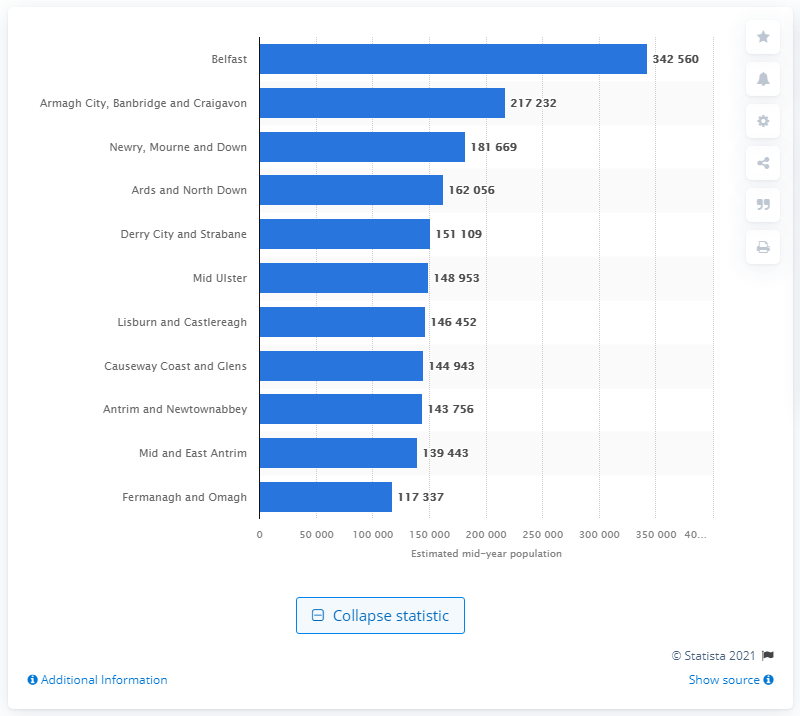Outline some significant characteristics in this image. In 2020, the estimated number of people living in Craigavon was 217,232. In 2020, the population of Belfast was approximately 342,560. 